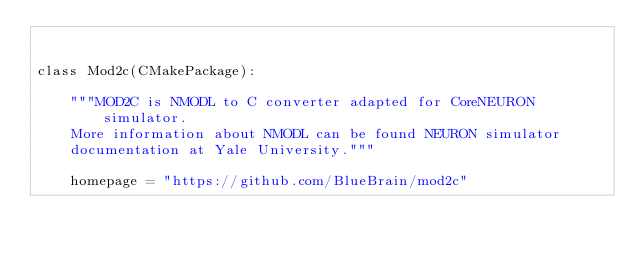<code> <loc_0><loc_0><loc_500><loc_500><_Python_>

class Mod2c(CMakePackage):

    """MOD2C is NMODL to C converter adapted for CoreNEURON simulator.
    More information about NMODL can be found NEURON simulator
    documentation at Yale University."""

    homepage = "https://github.com/BlueBrain/mod2c"</code> 